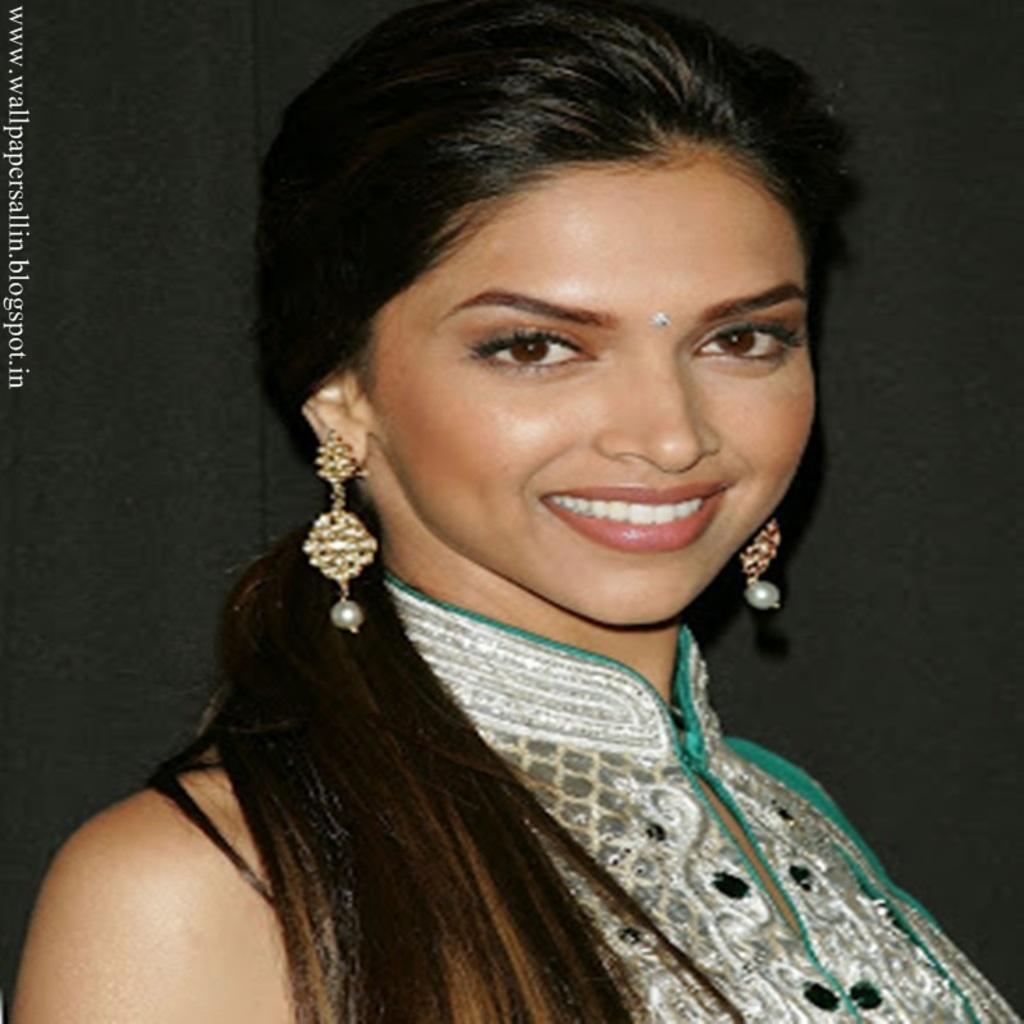Can you describe this image briefly? In this image we can see a woman wearing a dress with jewelry with a long hair. 